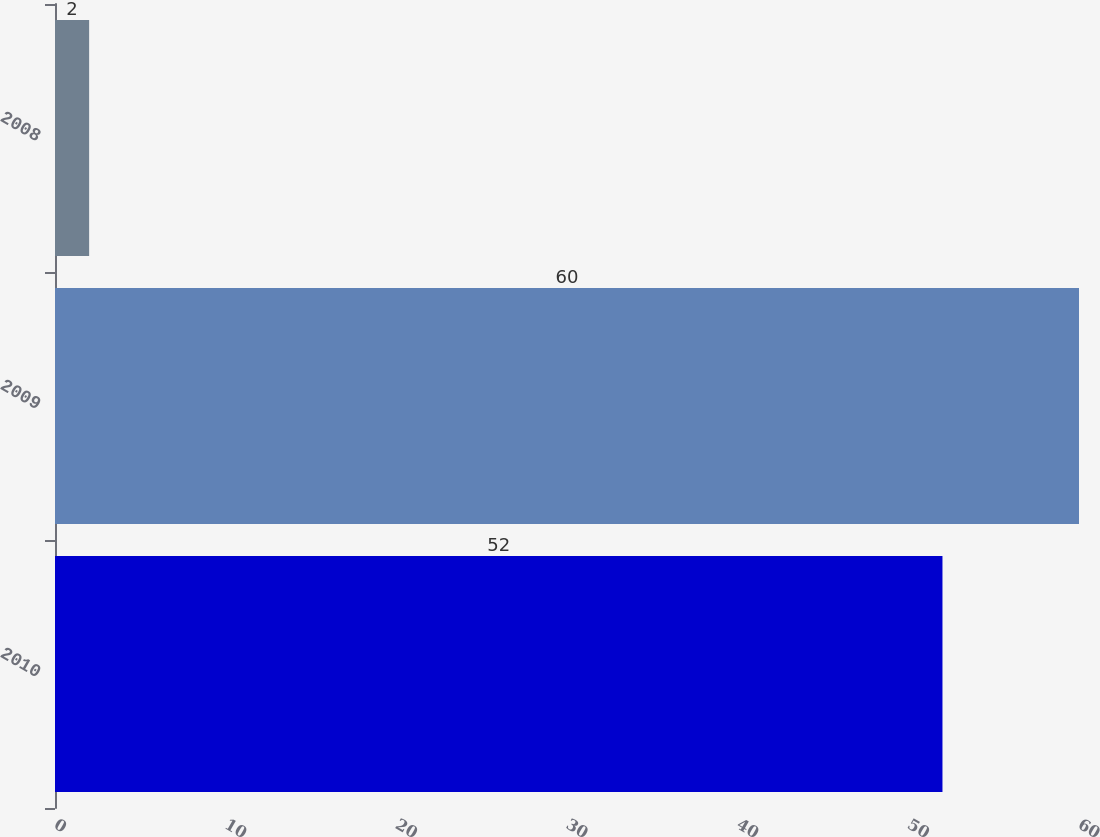<chart> <loc_0><loc_0><loc_500><loc_500><bar_chart><fcel>2010<fcel>2009<fcel>2008<nl><fcel>52<fcel>60<fcel>2<nl></chart> 